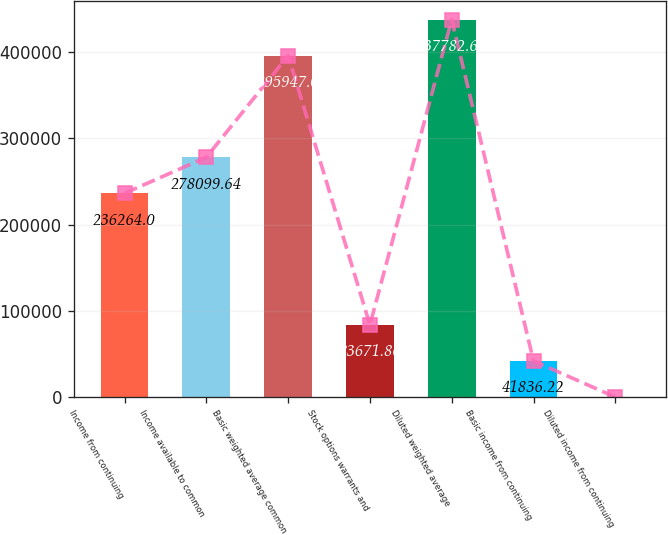Convert chart to OTSL. <chart><loc_0><loc_0><loc_500><loc_500><bar_chart><fcel>Income from continuing<fcel>Income available to common<fcel>Basic weighted average common<fcel>Stock options warrants and<fcel>Diluted weighted average<fcel>Basic income from continuing<fcel>Diluted income from continuing<nl><fcel>236264<fcel>278100<fcel>395947<fcel>83671.9<fcel>437783<fcel>41836.2<fcel>0.58<nl></chart> 